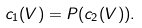<formula> <loc_0><loc_0><loc_500><loc_500>c _ { 1 } ( V ) = P ( c _ { 2 } ( V ) ) .</formula> 